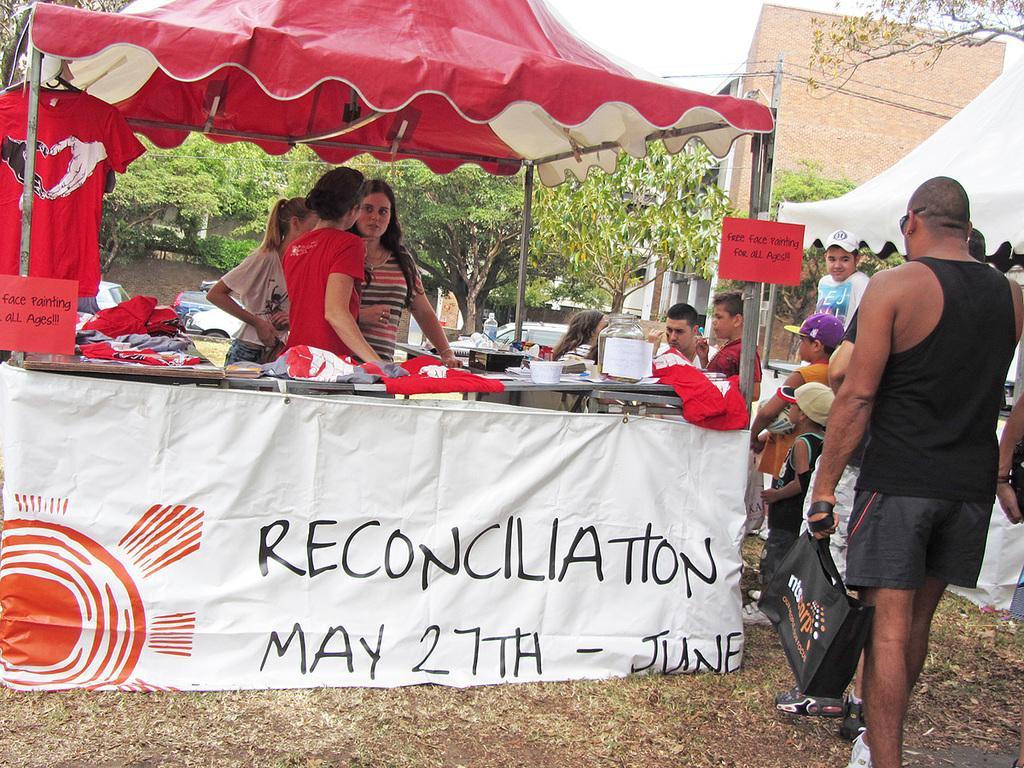Can you describe this image briefly? In the foreground I can see a food stall, board and a crowd on the ground. In the background I can see trees, buildings. On the top I can see the sky. This image is taken during a day on the ground. 